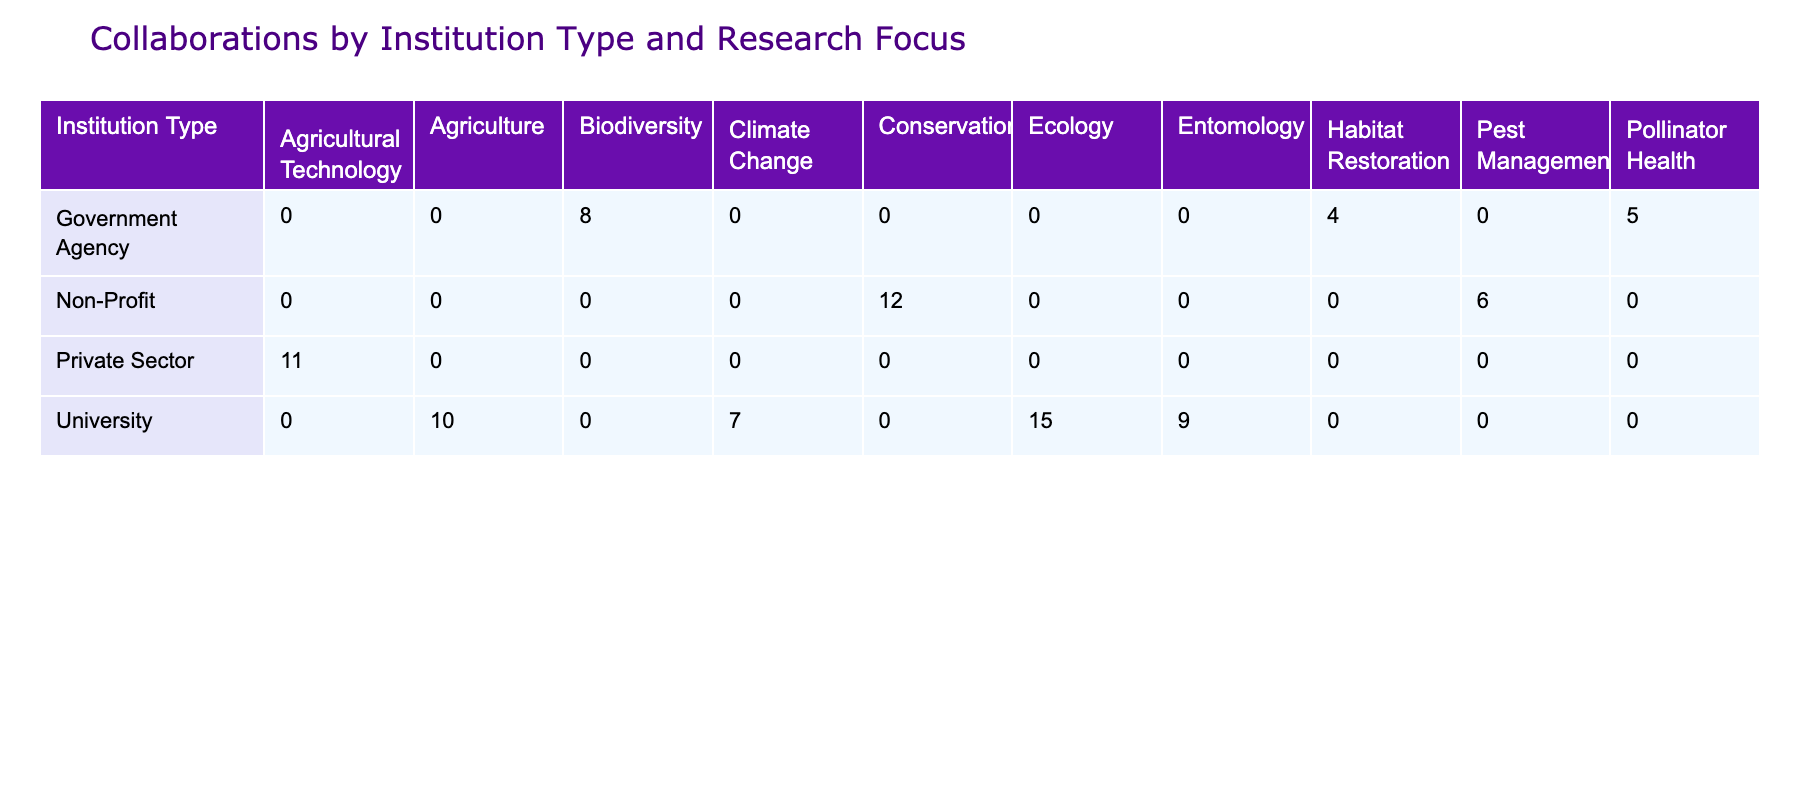What institution type has the highest number of collaborations in Ecology? The table shows that the University has 15 collaborations in Ecology, which is the highest value among all institution types listed.
Answer: University Which research focus has the lowest number of collaborations from Government Agencies? The table indicates that the research focus with the lowest collaborations from Government Agencies is Habitat Restoration, with a total of 4 collaborations.
Answer: Habitat Restoration What is the total number of collaborations for Non-Profit institutions across all research focuses? By adding the collaborations for Non-Profit institutions: Conservation (12) + Pest Management (6) = 18. Thus, the total is 18.
Answer: 18 Is the number of collaborations for private sector institutions in Agricultural Technology greater than the total collaborations for Government Agencies? The private sector has 11 collaborations in Agricultural Technology, while Government Agencies have a total of (8 + 5 + 4) = 17 collaborations across their research focuses. Therefore, it is false that the private sector has more collaborations.
Answer: No How many more collaborations do Universities have in Agriculture compared to Government Agencies in Pollinator Health? Universities have 10 collaborations in Agriculture, while Government Agencies have 5 collaborations in Pollinator Health. The difference is 10 - 5 = 5.
Answer: 5 Which institution type has 9 collaborations in Entomology? According to the table, the institution type that has 9 collaborations in Entomology is the University.
Answer: University What is the combined total of collaborations for Government Agencies and Non-Profit institutions? The total for Government Agencies is (8 + 5 + 4) = 17, and for Non-Profit institutions, it is (12 + 6) = 18. The combined total is 17 + 18 = 35.
Answer: 35 Does any institution type focus on both Pest Management and Conservation? From the data presented, Non-Profit institutions focus on both Pest Management (6 collaborations) and Conservation (12 collaborations). Thus, the answer is yes.
Answer: Yes 